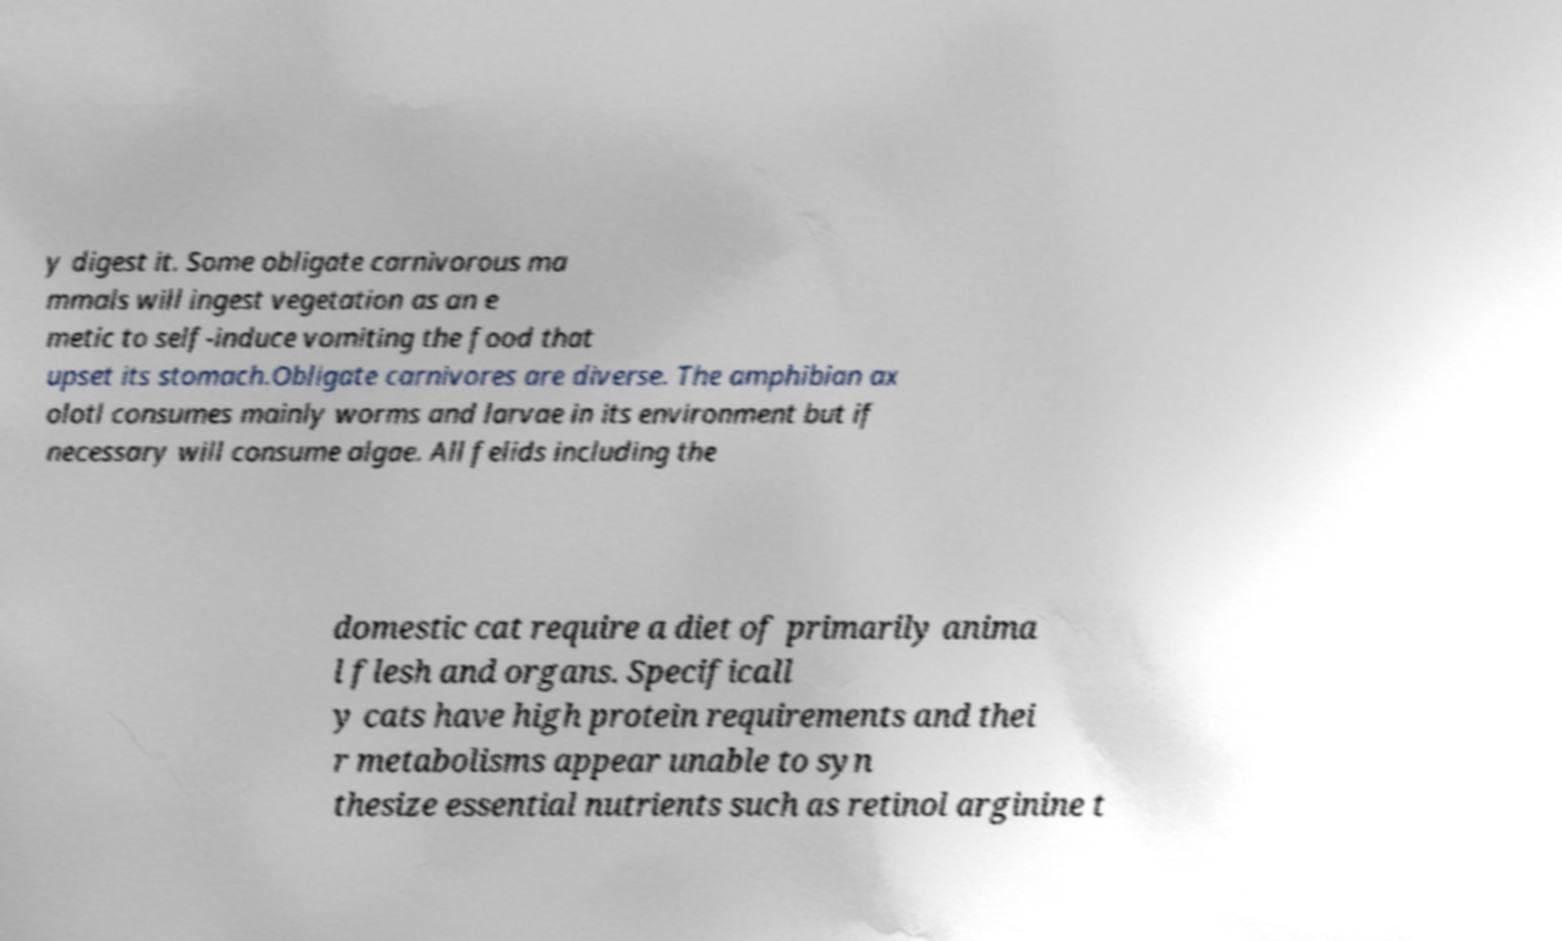For documentation purposes, I need the text within this image transcribed. Could you provide that? y digest it. Some obligate carnivorous ma mmals will ingest vegetation as an e metic to self-induce vomiting the food that upset its stomach.Obligate carnivores are diverse. The amphibian ax olotl consumes mainly worms and larvae in its environment but if necessary will consume algae. All felids including the domestic cat require a diet of primarily anima l flesh and organs. Specificall y cats have high protein requirements and thei r metabolisms appear unable to syn thesize essential nutrients such as retinol arginine t 